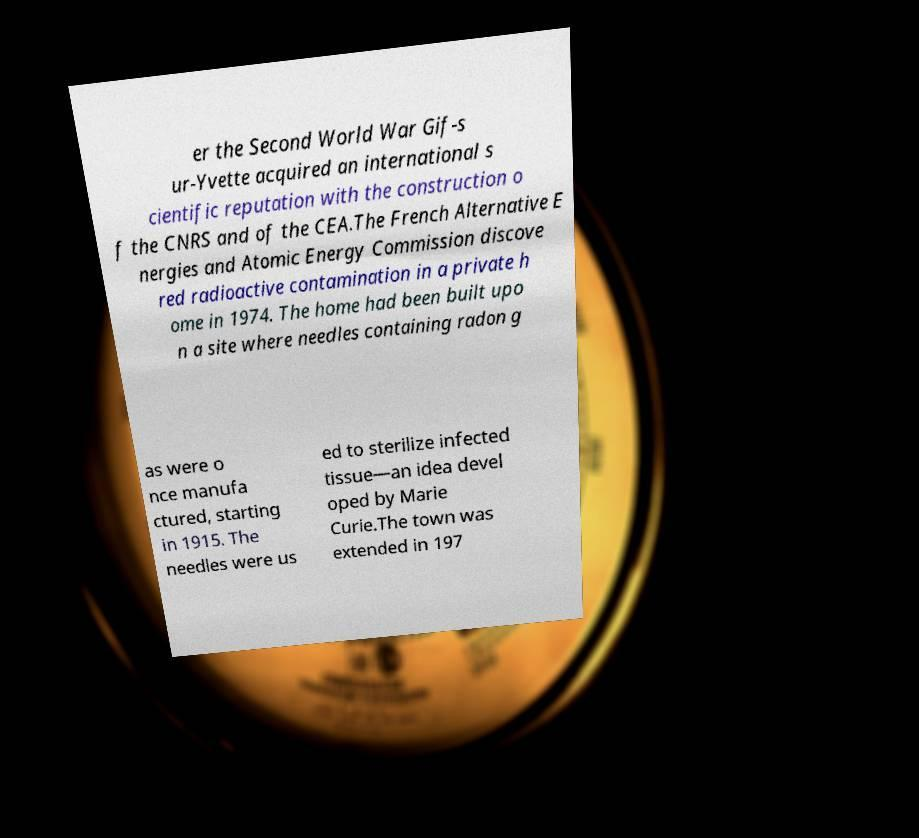Please read and relay the text visible in this image. What does it say? er the Second World War Gif-s ur-Yvette acquired an international s cientific reputation with the construction o f the CNRS and of the CEA.The French Alternative E nergies and Atomic Energy Commission discove red radioactive contamination in a private h ome in 1974. The home had been built upo n a site where needles containing radon g as were o nce manufa ctured, starting in 1915. The needles were us ed to sterilize infected tissue—an idea devel oped by Marie Curie.The town was extended in 197 